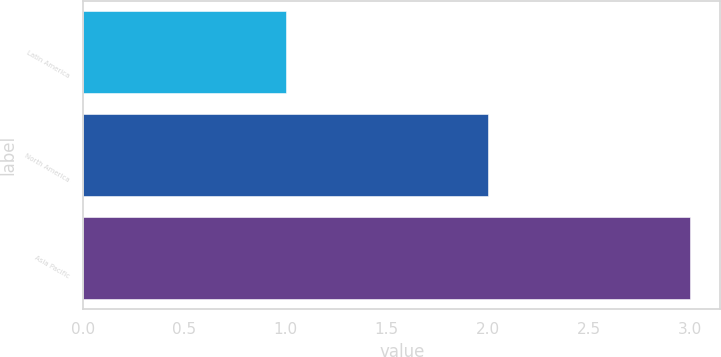<chart> <loc_0><loc_0><loc_500><loc_500><bar_chart><fcel>Latin America<fcel>North America<fcel>Asia Pacific<nl><fcel>1<fcel>2<fcel>3<nl></chart> 